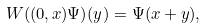<formula> <loc_0><loc_0><loc_500><loc_500>W ( ( 0 , x ) \Psi ) ( y ) = \Psi ( x + y ) ,</formula> 